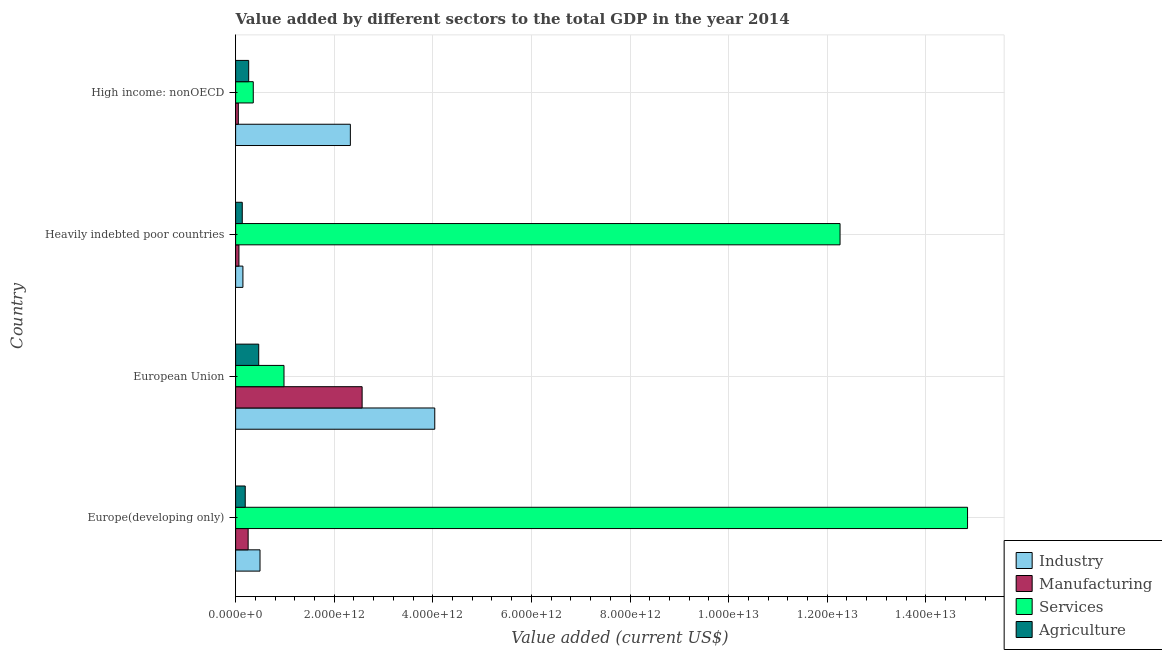How many different coloured bars are there?
Your answer should be compact. 4. How many groups of bars are there?
Make the answer very short. 4. How many bars are there on the 3rd tick from the top?
Ensure brevity in your answer.  4. How many bars are there on the 4th tick from the bottom?
Provide a succinct answer. 4. What is the value added by manufacturing sector in Heavily indebted poor countries?
Provide a short and direct response. 6.75e+1. Across all countries, what is the maximum value added by agricultural sector?
Provide a short and direct response. 4.69e+11. Across all countries, what is the minimum value added by services sector?
Your answer should be very brief. 3.58e+11. In which country was the value added by services sector maximum?
Ensure brevity in your answer.  Europe(developing only). In which country was the value added by industrial sector minimum?
Make the answer very short. Heavily indebted poor countries. What is the total value added by industrial sector in the graph?
Your answer should be compact. 7.01e+12. What is the difference between the value added by agricultural sector in Heavily indebted poor countries and that in High income: nonOECD?
Keep it short and to the point. -1.30e+11. What is the difference between the value added by services sector in High income: nonOECD and the value added by agricultural sector in European Union?
Your answer should be compact. -1.11e+11. What is the average value added by manufacturing sector per country?
Offer a terse response. 7.36e+11. What is the difference between the value added by manufacturing sector and value added by services sector in European Union?
Your answer should be compact. 1.58e+12. What is the ratio of the value added by agricultural sector in Europe(developing only) to that in Heavily indebted poor countries?
Offer a very short reply. 1.45. Is the value added by industrial sector in European Union less than that in High income: nonOECD?
Keep it short and to the point. No. Is the difference between the value added by industrial sector in Europe(developing only) and Heavily indebted poor countries greater than the difference between the value added by agricultural sector in Europe(developing only) and Heavily indebted poor countries?
Offer a terse response. Yes. What is the difference between the highest and the second highest value added by agricultural sector?
Provide a short and direct response. 2.04e+11. What is the difference between the highest and the lowest value added by services sector?
Keep it short and to the point. 1.45e+13. Is the sum of the value added by manufacturing sector in Heavily indebted poor countries and High income: nonOECD greater than the maximum value added by agricultural sector across all countries?
Give a very brief answer. No. What does the 2nd bar from the top in European Union represents?
Your response must be concise. Services. What does the 2nd bar from the bottom in High income: nonOECD represents?
Ensure brevity in your answer.  Manufacturing. Is it the case that in every country, the sum of the value added by industrial sector and value added by manufacturing sector is greater than the value added by services sector?
Offer a terse response. No. How many bars are there?
Ensure brevity in your answer.  16. How many countries are there in the graph?
Offer a terse response. 4. What is the difference between two consecutive major ticks on the X-axis?
Ensure brevity in your answer.  2.00e+12. Are the values on the major ticks of X-axis written in scientific E-notation?
Keep it short and to the point. Yes. Does the graph contain any zero values?
Give a very brief answer. No. Does the graph contain grids?
Your answer should be compact. Yes. How many legend labels are there?
Your response must be concise. 4. What is the title of the graph?
Keep it short and to the point. Value added by different sectors to the total GDP in the year 2014. What is the label or title of the X-axis?
Make the answer very short. Value added (current US$). What is the Value added (current US$) of Industry in Europe(developing only)?
Your answer should be very brief. 4.95e+11. What is the Value added (current US$) of Manufacturing in Europe(developing only)?
Offer a terse response. 2.54e+11. What is the Value added (current US$) in Services in Europe(developing only)?
Provide a succinct answer. 1.48e+13. What is the Value added (current US$) of Agriculture in Europe(developing only)?
Keep it short and to the point. 1.95e+11. What is the Value added (current US$) of Industry in European Union?
Your response must be concise. 4.04e+12. What is the Value added (current US$) of Manufacturing in European Union?
Your answer should be compact. 2.57e+12. What is the Value added (current US$) in Services in European Union?
Your answer should be compact. 9.81e+11. What is the Value added (current US$) of Agriculture in European Union?
Your response must be concise. 4.69e+11. What is the Value added (current US$) in Industry in Heavily indebted poor countries?
Offer a very short reply. 1.48e+11. What is the Value added (current US$) of Manufacturing in Heavily indebted poor countries?
Provide a short and direct response. 6.75e+1. What is the Value added (current US$) of Services in Heavily indebted poor countries?
Offer a very short reply. 1.23e+13. What is the Value added (current US$) of Agriculture in Heavily indebted poor countries?
Keep it short and to the point. 1.35e+11. What is the Value added (current US$) in Industry in High income: nonOECD?
Your answer should be very brief. 2.33e+12. What is the Value added (current US$) in Manufacturing in High income: nonOECD?
Offer a very short reply. 5.49e+1. What is the Value added (current US$) of Services in High income: nonOECD?
Ensure brevity in your answer.  3.58e+11. What is the Value added (current US$) in Agriculture in High income: nonOECD?
Make the answer very short. 2.65e+11. Across all countries, what is the maximum Value added (current US$) in Industry?
Provide a short and direct response. 4.04e+12. Across all countries, what is the maximum Value added (current US$) in Manufacturing?
Offer a very short reply. 2.57e+12. Across all countries, what is the maximum Value added (current US$) in Services?
Keep it short and to the point. 1.48e+13. Across all countries, what is the maximum Value added (current US$) in Agriculture?
Provide a short and direct response. 4.69e+11. Across all countries, what is the minimum Value added (current US$) of Industry?
Make the answer very short. 1.48e+11. Across all countries, what is the minimum Value added (current US$) of Manufacturing?
Provide a short and direct response. 5.49e+1. Across all countries, what is the minimum Value added (current US$) in Services?
Offer a very short reply. 3.58e+11. Across all countries, what is the minimum Value added (current US$) in Agriculture?
Offer a very short reply. 1.35e+11. What is the total Value added (current US$) in Industry in the graph?
Provide a short and direct response. 7.01e+12. What is the total Value added (current US$) of Manufacturing in the graph?
Give a very brief answer. 2.94e+12. What is the total Value added (current US$) in Services in the graph?
Your answer should be very brief. 2.84e+13. What is the total Value added (current US$) of Agriculture in the graph?
Ensure brevity in your answer.  1.06e+12. What is the difference between the Value added (current US$) in Industry in Europe(developing only) and that in European Union?
Provide a succinct answer. -3.54e+12. What is the difference between the Value added (current US$) in Manufacturing in Europe(developing only) and that in European Union?
Your response must be concise. -2.31e+12. What is the difference between the Value added (current US$) in Services in Europe(developing only) and that in European Union?
Make the answer very short. 1.39e+13. What is the difference between the Value added (current US$) of Agriculture in Europe(developing only) and that in European Union?
Ensure brevity in your answer.  -2.74e+11. What is the difference between the Value added (current US$) of Industry in Europe(developing only) and that in Heavily indebted poor countries?
Your response must be concise. 3.47e+11. What is the difference between the Value added (current US$) of Manufacturing in Europe(developing only) and that in Heavily indebted poor countries?
Ensure brevity in your answer.  1.87e+11. What is the difference between the Value added (current US$) of Services in Europe(developing only) and that in Heavily indebted poor countries?
Your response must be concise. 2.59e+12. What is the difference between the Value added (current US$) of Agriculture in Europe(developing only) and that in Heavily indebted poor countries?
Provide a short and direct response. 6.02e+1. What is the difference between the Value added (current US$) of Industry in Europe(developing only) and that in High income: nonOECD?
Give a very brief answer. -1.83e+12. What is the difference between the Value added (current US$) of Manufacturing in Europe(developing only) and that in High income: nonOECD?
Your answer should be very brief. 1.99e+11. What is the difference between the Value added (current US$) of Services in Europe(developing only) and that in High income: nonOECD?
Give a very brief answer. 1.45e+13. What is the difference between the Value added (current US$) in Agriculture in Europe(developing only) and that in High income: nonOECD?
Offer a terse response. -7.00e+1. What is the difference between the Value added (current US$) of Industry in European Union and that in Heavily indebted poor countries?
Your answer should be compact. 3.89e+12. What is the difference between the Value added (current US$) in Manufacturing in European Union and that in Heavily indebted poor countries?
Provide a short and direct response. 2.50e+12. What is the difference between the Value added (current US$) of Services in European Union and that in Heavily indebted poor countries?
Your answer should be very brief. -1.13e+13. What is the difference between the Value added (current US$) of Agriculture in European Union and that in Heavily indebted poor countries?
Offer a terse response. 3.34e+11. What is the difference between the Value added (current US$) of Industry in European Union and that in High income: nonOECD?
Keep it short and to the point. 1.71e+12. What is the difference between the Value added (current US$) in Manufacturing in European Union and that in High income: nonOECD?
Keep it short and to the point. 2.51e+12. What is the difference between the Value added (current US$) of Services in European Union and that in High income: nonOECD?
Ensure brevity in your answer.  6.23e+11. What is the difference between the Value added (current US$) in Agriculture in European Union and that in High income: nonOECD?
Make the answer very short. 2.04e+11. What is the difference between the Value added (current US$) in Industry in Heavily indebted poor countries and that in High income: nonOECD?
Keep it short and to the point. -2.18e+12. What is the difference between the Value added (current US$) in Manufacturing in Heavily indebted poor countries and that in High income: nonOECD?
Provide a short and direct response. 1.26e+1. What is the difference between the Value added (current US$) of Services in Heavily indebted poor countries and that in High income: nonOECD?
Ensure brevity in your answer.  1.19e+13. What is the difference between the Value added (current US$) of Agriculture in Heavily indebted poor countries and that in High income: nonOECD?
Keep it short and to the point. -1.30e+11. What is the difference between the Value added (current US$) of Industry in Europe(developing only) and the Value added (current US$) of Manufacturing in European Union?
Keep it short and to the point. -2.07e+12. What is the difference between the Value added (current US$) of Industry in Europe(developing only) and the Value added (current US$) of Services in European Union?
Offer a terse response. -4.86e+11. What is the difference between the Value added (current US$) of Industry in Europe(developing only) and the Value added (current US$) of Agriculture in European Union?
Keep it short and to the point. 2.64e+1. What is the difference between the Value added (current US$) in Manufacturing in Europe(developing only) and the Value added (current US$) in Services in European Union?
Make the answer very short. -7.27e+11. What is the difference between the Value added (current US$) in Manufacturing in Europe(developing only) and the Value added (current US$) in Agriculture in European Union?
Ensure brevity in your answer.  -2.15e+11. What is the difference between the Value added (current US$) of Services in Europe(developing only) and the Value added (current US$) of Agriculture in European Union?
Give a very brief answer. 1.44e+13. What is the difference between the Value added (current US$) of Industry in Europe(developing only) and the Value added (current US$) of Manufacturing in Heavily indebted poor countries?
Provide a short and direct response. 4.28e+11. What is the difference between the Value added (current US$) of Industry in Europe(developing only) and the Value added (current US$) of Services in Heavily indebted poor countries?
Ensure brevity in your answer.  -1.18e+13. What is the difference between the Value added (current US$) in Industry in Europe(developing only) and the Value added (current US$) in Agriculture in Heavily indebted poor countries?
Offer a very short reply. 3.60e+11. What is the difference between the Value added (current US$) in Manufacturing in Europe(developing only) and the Value added (current US$) in Services in Heavily indebted poor countries?
Provide a short and direct response. -1.20e+13. What is the difference between the Value added (current US$) in Manufacturing in Europe(developing only) and the Value added (current US$) in Agriculture in Heavily indebted poor countries?
Your response must be concise. 1.19e+11. What is the difference between the Value added (current US$) of Services in Europe(developing only) and the Value added (current US$) of Agriculture in Heavily indebted poor countries?
Your answer should be very brief. 1.47e+13. What is the difference between the Value added (current US$) in Industry in Europe(developing only) and the Value added (current US$) in Manufacturing in High income: nonOECD?
Provide a succinct answer. 4.40e+11. What is the difference between the Value added (current US$) of Industry in Europe(developing only) and the Value added (current US$) of Services in High income: nonOECD?
Provide a short and direct response. 1.37e+11. What is the difference between the Value added (current US$) in Industry in Europe(developing only) and the Value added (current US$) in Agriculture in High income: nonOECD?
Your answer should be compact. 2.30e+11. What is the difference between the Value added (current US$) of Manufacturing in Europe(developing only) and the Value added (current US$) of Services in High income: nonOECD?
Keep it short and to the point. -1.04e+11. What is the difference between the Value added (current US$) in Manufacturing in Europe(developing only) and the Value added (current US$) in Agriculture in High income: nonOECD?
Offer a very short reply. -1.09e+1. What is the difference between the Value added (current US$) of Services in Europe(developing only) and the Value added (current US$) of Agriculture in High income: nonOECD?
Offer a very short reply. 1.46e+13. What is the difference between the Value added (current US$) in Industry in European Union and the Value added (current US$) in Manufacturing in Heavily indebted poor countries?
Make the answer very short. 3.97e+12. What is the difference between the Value added (current US$) in Industry in European Union and the Value added (current US$) in Services in Heavily indebted poor countries?
Offer a very short reply. -8.22e+12. What is the difference between the Value added (current US$) of Industry in European Union and the Value added (current US$) of Agriculture in Heavily indebted poor countries?
Give a very brief answer. 3.90e+12. What is the difference between the Value added (current US$) of Manufacturing in European Union and the Value added (current US$) of Services in Heavily indebted poor countries?
Keep it short and to the point. -9.69e+12. What is the difference between the Value added (current US$) in Manufacturing in European Union and the Value added (current US$) in Agriculture in Heavily indebted poor countries?
Offer a terse response. 2.43e+12. What is the difference between the Value added (current US$) in Services in European Union and the Value added (current US$) in Agriculture in Heavily indebted poor countries?
Your answer should be very brief. 8.46e+11. What is the difference between the Value added (current US$) in Industry in European Union and the Value added (current US$) in Manufacturing in High income: nonOECD?
Your answer should be very brief. 3.98e+12. What is the difference between the Value added (current US$) in Industry in European Union and the Value added (current US$) in Services in High income: nonOECD?
Offer a very short reply. 3.68e+12. What is the difference between the Value added (current US$) in Industry in European Union and the Value added (current US$) in Agriculture in High income: nonOECD?
Make the answer very short. 3.77e+12. What is the difference between the Value added (current US$) in Manufacturing in European Union and the Value added (current US$) in Services in High income: nonOECD?
Your response must be concise. 2.21e+12. What is the difference between the Value added (current US$) of Manufacturing in European Union and the Value added (current US$) of Agriculture in High income: nonOECD?
Offer a very short reply. 2.30e+12. What is the difference between the Value added (current US$) of Services in European Union and the Value added (current US$) of Agriculture in High income: nonOECD?
Your answer should be very brief. 7.16e+11. What is the difference between the Value added (current US$) of Industry in Heavily indebted poor countries and the Value added (current US$) of Manufacturing in High income: nonOECD?
Provide a succinct answer. 9.32e+1. What is the difference between the Value added (current US$) of Industry in Heavily indebted poor countries and the Value added (current US$) of Services in High income: nonOECD?
Offer a very short reply. -2.10e+11. What is the difference between the Value added (current US$) in Industry in Heavily indebted poor countries and the Value added (current US$) in Agriculture in High income: nonOECD?
Your answer should be very brief. -1.17e+11. What is the difference between the Value added (current US$) in Manufacturing in Heavily indebted poor countries and the Value added (current US$) in Services in High income: nonOECD?
Your answer should be very brief. -2.91e+11. What is the difference between the Value added (current US$) of Manufacturing in Heavily indebted poor countries and the Value added (current US$) of Agriculture in High income: nonOECD?
Your answer should be compact. -1.97e+11. What is the difference between the Value added (current US$) of Services in Heavily indebted poor countries and the Value added (current US$) of Agriculture in High income: nonOECD?
Provide a short and direct response. 1.20e+13. What is the average Value added (current US$) in Industry per country?
Offer a terse response. 1.75e+12. What is the average Value added (current US$) in Manufacturing per country?
Offer a very short reply. 7.36e+11. What is the average Value added (current US$) in Services per country?
Keep it short and to the point. 7.11e+12. What is the average Value added (current US$) of Agriculture per country?
Provide a succinct answer. 2.66e+11. What is the difference between the Value added (current US$) in Industry and Value added (current US$) in Manufacturing in Europe(developing only)?
Keep it short and to the point. 2.41e+11. What is the difference between the Value added (current US$) in Industry and Value added (current US$) in Services in Europe(developing only)?
Keep it short and to the point. -1.44e+13. What is the difference between the Value added (current US$) in Industry and Value added (current US$) in Agriculture in Europe(developing only)?
Provide a short and direct response. 3.00e+11. What is the difference between the Value added (current US$) of Manufacturing and Value added (current US$) of Services in Europe(developing only)?
Make the answer very short. -1.46e+13. What is the difference between the Value added (current US$) of Manufacturing and Value added (current US$) of Agriculture in Europe(developing only)?
Offer a terse response. 5.91e+1. What is the difference between the Value added (current US$) of Services and Value added (current US$) of Agriculture in Europe(developing only)?
Provide a succinct answer. 1.47e+13. What is the difference between the Value added (current US$) of Industry and Value added (current US$) of Manufacturing in European Union?
Your answer should be compact. 1.47e+12. What is the difference between the Value added (current US$) of Industry and Value added (current US$) of Services in European Union?
Ensure brevity in your answer.  3.06e+12. What is the difference between the Value added (current US$) of Industry and Value added (current US$) of Agriculture in European Union?
Make the answer very short. 3.57e+12. What is the difference between the Value added (current US$) in Manufacturing and Value added (current US$) in Services in European Union?
Offer a very short reply. 1.58e+12. What is the difference between the Value added (current US$) of Manufacturing and Value added (current US$) of Agriculture in European Union?
Keep it short and to the point. 2.10e+12. What is the difference between the Value added (current US$) of Services and Value added (current US$) of Agriculture in European Union?
Your response must be concise. 5.13e+11. What is the difference between the Value added (current US$) in Industry and Value added (current US$) in Manufacturing in Heavily indebted poor countries?
Keep it short and to the point. 8.05e+1. What is the difference between the Value added (current US$) in Industry and Value added (current US$) in Services in Heavily indebted poor countries?
Make the answer very short. -1.21e+13. What is the difference between the Value added (current US$) of Industry and Value added (current US$) of Agriculture in Heavily indebted poor countries?
Your answer should be compact. 1.33e+1. What is the difference between the Value added (current US$) in Manufacturing and Value added (current US$) in Services in Heavily indebted poor countries?
Your response must be concise. -1.22e+13. What is the difference between the Value added (current US$) in Manufacturing and Value added (current US$) in Agriculture in Heavily indebted poor countries?
Your answer should be very brief. -6.73e+1. What is the difference between the Value added (current US$) of Services and Value added (current US$) of Agriculture in Heavily indebted poor countries?
Provide a succinct answer. 1.21e+13. What is the difference between the Value added (current US$) of Industry and Value added (current US$) of Manufacturing in High income: nonOECD?
Offer a terse response. 2.27e+12. What is the difference between the Value added (current US$) of Industry and Value added (current US$) of Services in High income: nonOECD?
Your response must be concise. 1.97e+12. What is the difference between the Value added (current US$) of Industry and Value added (current US$) of Agriculture in High income: nonOECD?
Keep it short and to the point. 2.06e+12. What is the difference between the Value added (current US$) of Manufacturing and Value added (current US$) of Services in High income: nonOECD?
Give a very brief answer. -3.03e+11. What is the difference between the Value added (current US$) in Manufacturing and Value added (current US$) in Agriculture in High income: nonOECD?
Your answer should be compact. -2.10e+11. What is the difference between the Value added (current US$) of Services and Value added (current US$) of Agriculture in High income: nonOECD?
Make the answer very short. 9.31e+1. What is the ratio of the Value added (current US$) of Industry in Europe(developing only) to that in European Union?
Offer a terse response. 0.12. What is the ratio of the Value added (current US$) of Manufacturing in Europe(developing only) to that in European Union?
Offer a very short reply. 0.1. What is the ratio of the Value added (current US$) in Services in Europe(developing only) to that in European Union?
Offer a very short reply. 15.13. What is the ratio of the Value added (current US$) of Agriculture in Europe(developing only) to that in European Union?
Your answer should be very brief. 0.42. What is the ratio of the Value added (current US$) in Industry in Europe(developing only) to that in Heavily indebted poor countries?
Offer a terse response. 3.34. What is the ratio of the Value added (current US$) in Manufacturing in Europe(developing only) to that in Heavily indebted poor countries?
Offer a very short reply. 3.76. What is the ratio of the Value added (current US$) of Services in Europe(developing only) to that in Heavily indebted poor countries?
Make the answer very short. 1.21. What is the ratio of the Value added (current US$) in Agriculture in Europe(developing only) to that in Heavily indebted poor countries?
Give a very brief answer. 1.45. What is the ratio of the Value added (current US$) in Industry in Europe(developing only) to that in High income: nonOECD?
Make the answer very short. 0.21. What is the ratio of the Value added (current US$) in Manufacturing in Europe(developing only) to that in High income: nonOECD?
Your response must be concise. 4.63. What is the ratio of the Value added (current US$) of Services in Europe(developing only) to that in High income: nonOECD?
Your response must be concise. 41.46. What is the ratio of the Value added (current US$) in Agriculture in Europe(developing only) to that in High income: nonOECD?
Offer a very short reply. 0.74. What is the ratio of the Value added (current US$) in Industry in European Union to that in Heavily indebted poor countries?
Offer a terse response. 27.29. What is the ratio of the Value added (current US$) in Manufacturing in European Union to that in Heavily indebted poor countries?
Keep it short and to the point. 38.02. What is the ratio of the Value added (current US$) of Services in European Union to that in Heavily indebted poor countries?
Provide a short and direct response. 0.08. What is the ratio of the Value added (current US$) of Agriculture in European Union to that in Heavily indebted poor countries?
Make the answer very short. 3.48. What is the ratio of the Value added (current US$) in Industry in European Union to that in High income: nonOECD?
Provide a succinct answer. 1.74. What is the ratio of the Value added (current US$) in Manufacturing in European Union to that in High income: nonOECD?
Provide a short and direct response. 46.75. What is the ratio of the Value added (current US$) of Services in European Union to that in High income: nonOECD?
Ensure brevity in your answer.  2.74. What is the ratio of the Value added (current US$) in Agriculture in European Union to that in High income: nonOECD?
Your answer should be compact. 1.77. What is the ratio of the Value added (current US$) in Industry in Heavily indebted poor countries to that in High income: nonOECD?
Give a very brief answer. 0.06. What is the ratio of the Value added (current US$) in Manufacturing in Heavily indebted poor countries to that in High income: nonOECD?
Your response must be concise. 1.23. What is the ratio of the Value added (current US$) of Services in Heavily indebted poor countries to that in High income: nonOECD?
Your response must be concise. 34.24. What is the ratio of the Value added (current US$) in Agriculture in Heavily indebted poor countries to that in High income: nonOECD?
Provide a short and direct response. 0.51. What is the difference between the highest and the second highest Value added (current US$) in Industry?
Offer a terse response. 1.71e+12. What is the difference between the highest and the second highest Value added (current US$) of Manufacturing?
Provide a short and direct response. 2.31e+12. What is the difference between the highest and the second highest Value added (current US$) in Services?
Your answer should be very brief. 2.59e+12. What is the difference between the highest and the second highest Value added (current US$) in Agriculture?
Your answer should be compact. 2.04e+11. What is the difference between the highest and the lowest Value added (current US$) of Industry?
Your response must be concise. 3.89e+12. What is the difference between the highest and the lowest Value added (current US$) of Manufacturing?
Make the answer very short. 2.51e+12. What is the difference between the highest and the lowest Value added (current US$) in Services?
Ensure brevity in your answer.  1.45e+13. What is the difference between the highest and the lowest Value added (current US$) in Agriculture?
Your response must be concise. 3.34e+11. 